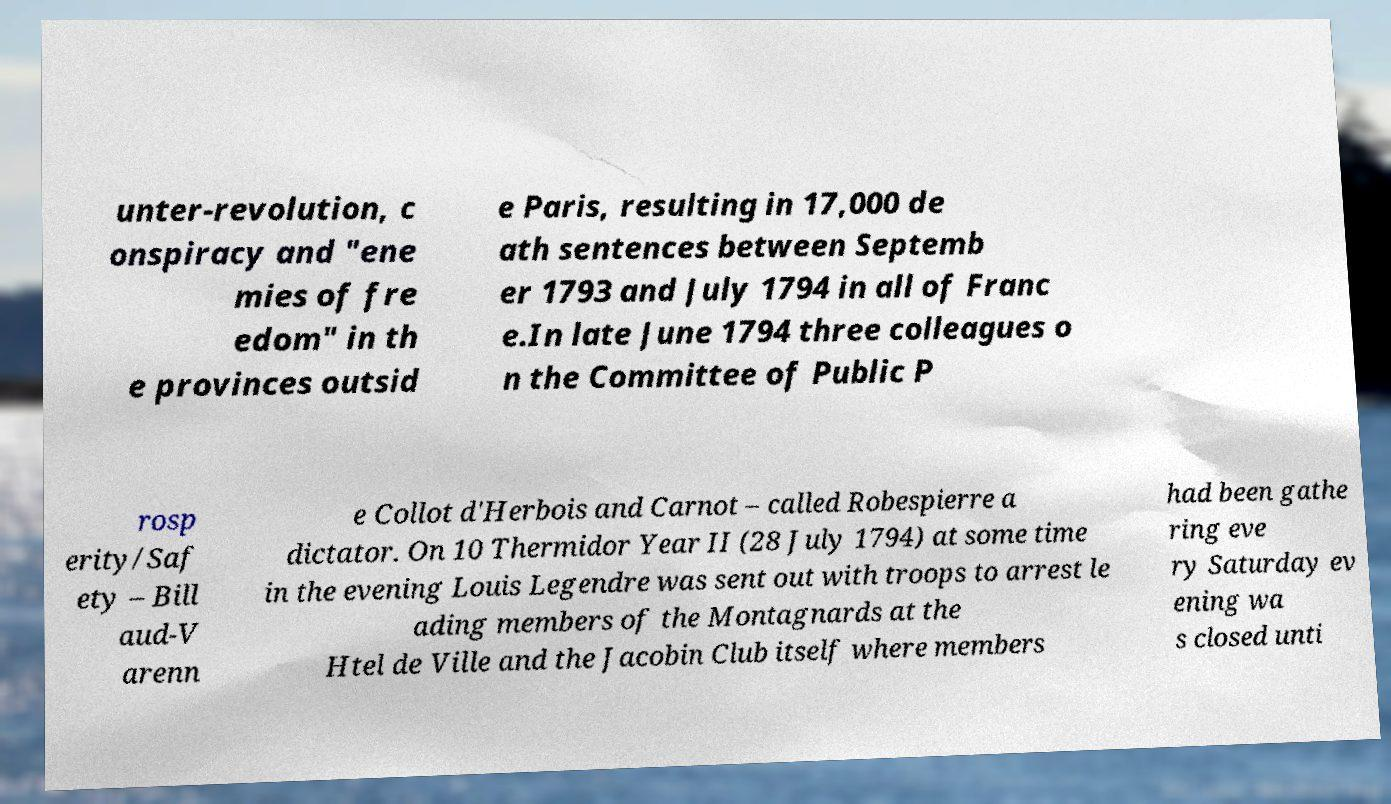I need the written content from this picture converted into text. Can you do that? unter-revolution, c onspiracy and "ene mies of fre edom" in th e provinces outsid e Paris, resulting in 17,000 de ath sentences between Septemb er 1793 and July 1794 in all of Franc e.In late June 1794 three colleagues o n the Committee of Public P rosp erity/Saf ety – Bill aud-V arenn e Collot d'Herbois and Carnot – called Robespierre a dictator. On 10 Thermidor Year II (28 July 1794) at some time in the evening Louis Legendre was sent out with troops to arrest le ading members of the Montagnards at the Htel de Ville and the Jacobin Club itself where members had been gathe ring eve ry Saturday ev ening wa s closed unti 